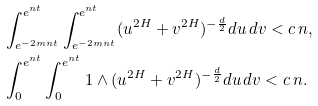<formula> <loc_0><loc_0><loc_500><loc_500>& \int ^ { e ^ { n t } } _ { e ^ { - 2 m n t } } \int ^ { e ^ { n t } } _ { e ^ { - 2 m n t } } ( u ^ { 2 H } + v ^ { 2 H } ) ^ { - \frac { d } { 2 } } d u \, d v < c \, n , \\ & \int ^ { e ^ { n t } } _ { 0 } \int ^ { e ^ { n t } } _ { 0 } 1 \wedge ( u ^ { 2 H } + v ^ { 2 H } ) ^ { - \frac { d } { 2 } } d u \, d v < c \, n .</formula> 